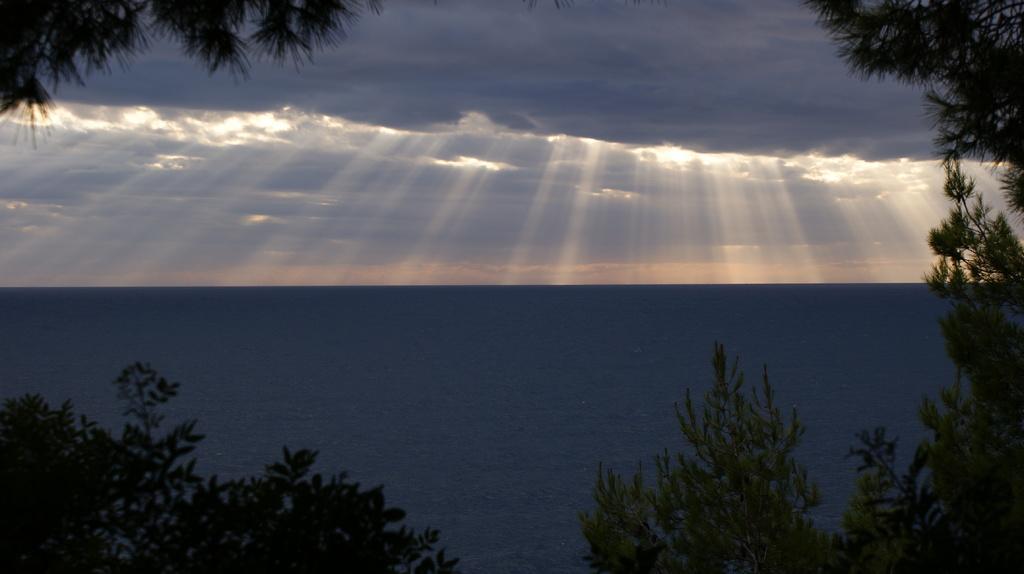In one or two sentences, can you explain what this image depicts? In this image we can see some trees, water and top of the image there is cloudy sky and we can see some rays falling on water. 